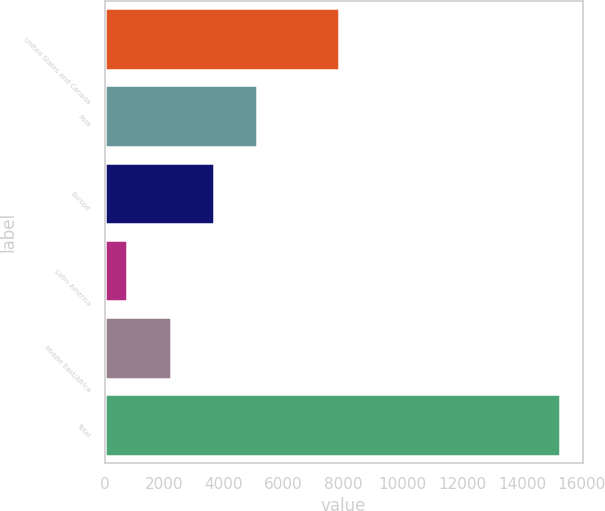<chart> <loc_0><loc_0><loc_500><loc_500><bar_chart><fcel>United States and Canada<fcel>Asia<fcel>Europe<fcel>Latin America<fcel>Middle East/Africa<fcel>Total<nl><fcel>7854<fcel>5116.1<fcel>3666.4<fcel>767<fcel>2216.7<fcel>15264<nl></chart> 